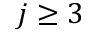<formula> <loc_0><loc_0><loc_500><loc_500>j \geq 3</formula> 